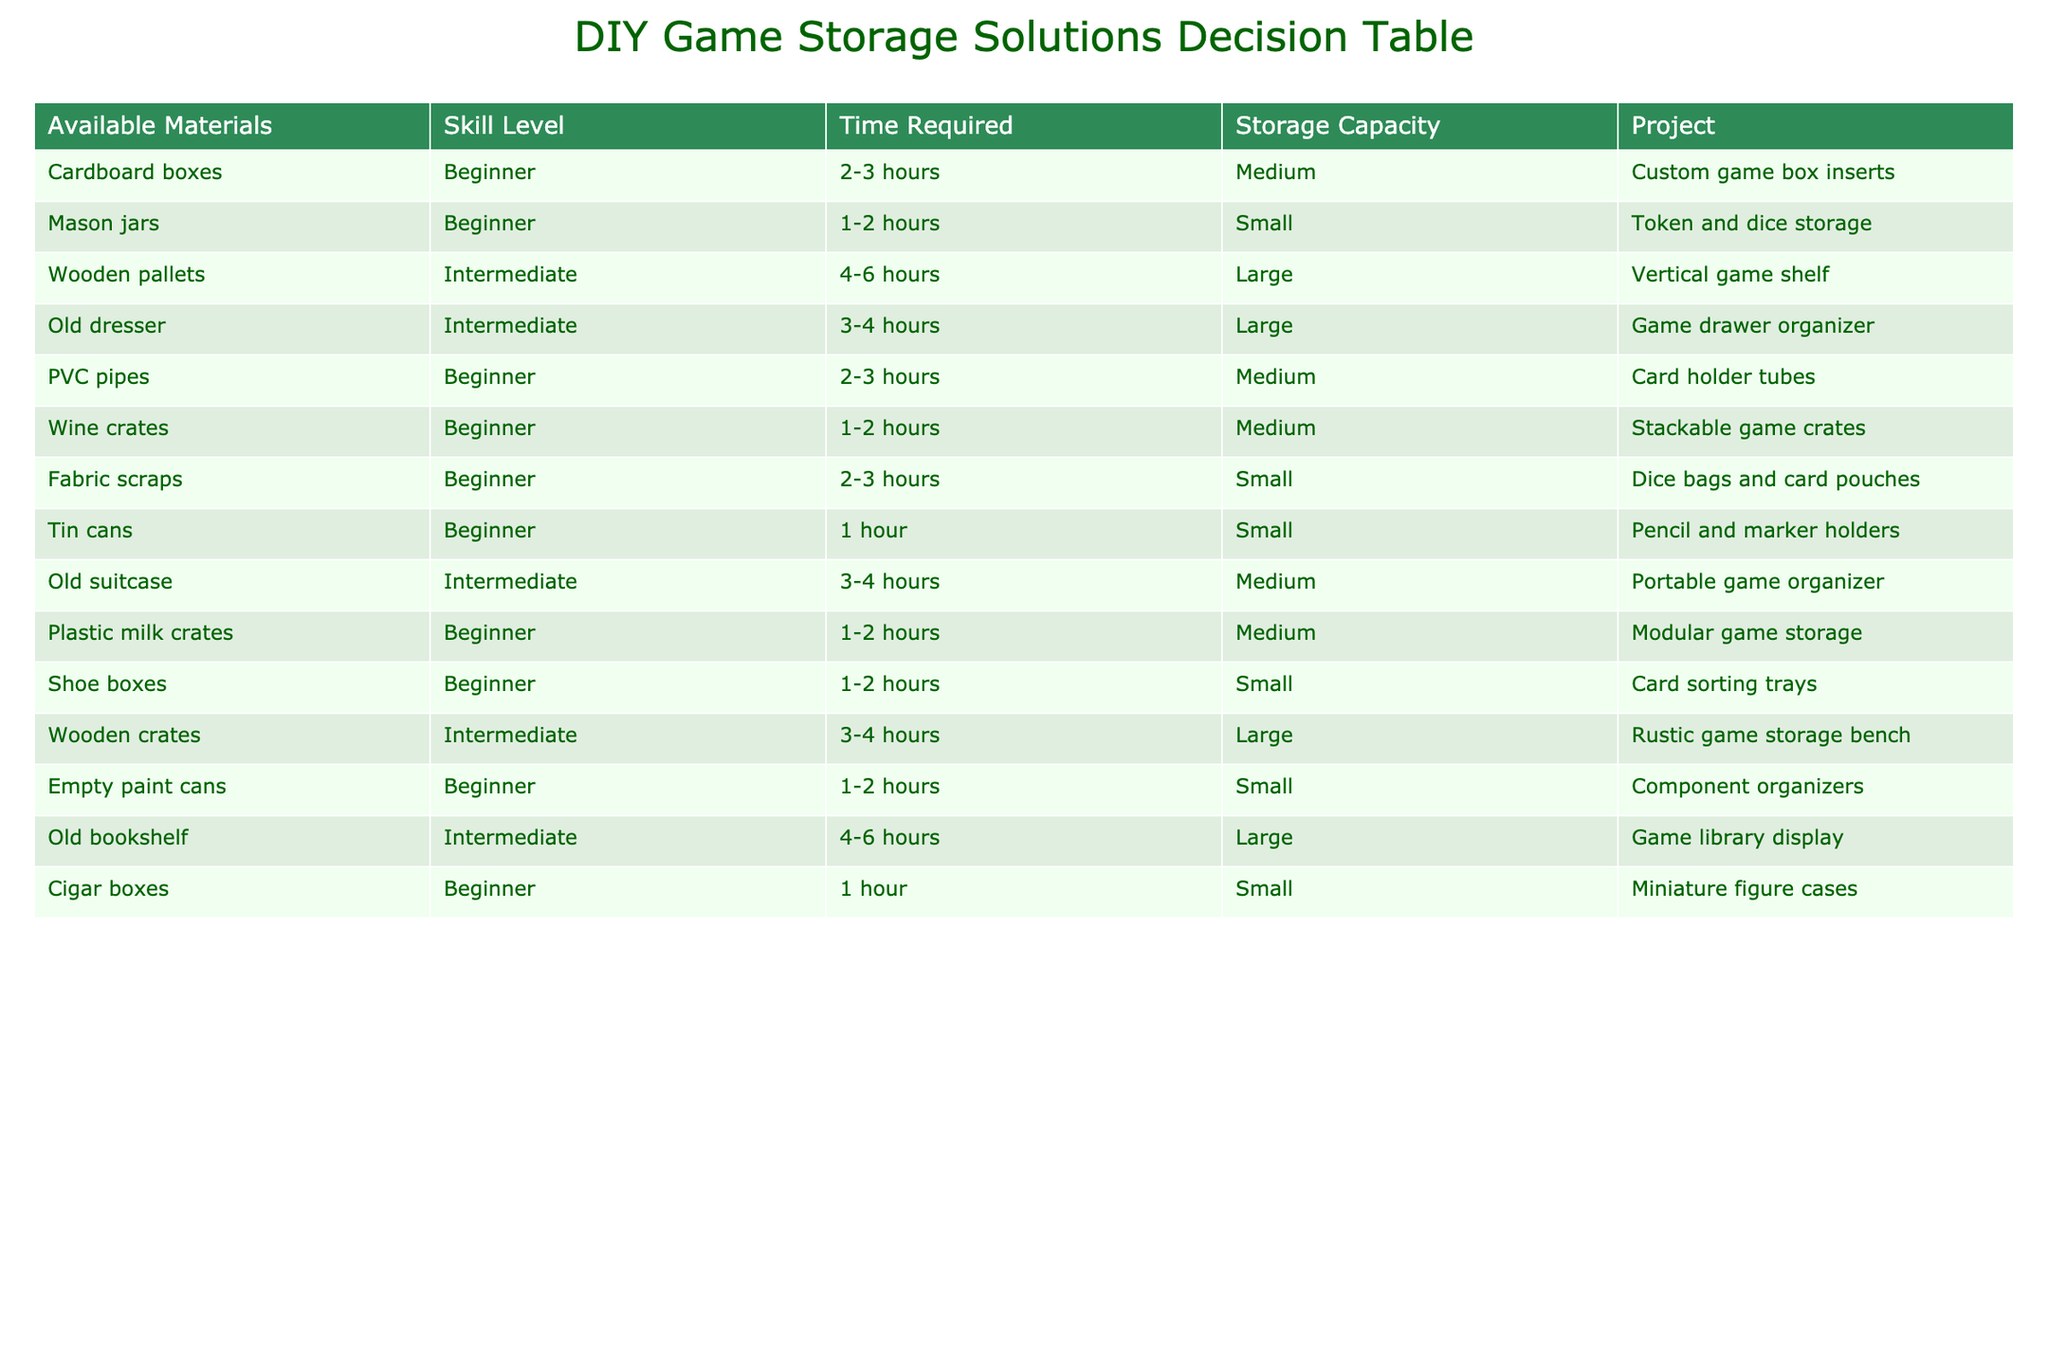What is the skill level required for making custom game box inserts? The project "Custom game box inserts" has the skill level marked as "Beginner" in the table.
Answer: Beginner How many projects require an intermediate skill level? By counting the entire table, there are 4 projects listed with an intermediate skill level.
Answer: 4 What is the storage capacity of the vertical game shelf project? The project "Vertical game shelf" has a storage capacity classified as "Large" in the table.
Answer: Large Which projects can be completed in 1-2 hours and require beginner skill level? Filtering the table for projects that are marked with "Beginner" skill level and have "1-2 hours" time, the projects are: "Mason jars" and "Plastic milk crates".
Answer: Mason jars, Plastic milk crates What is the average time required for all projects? Summing up the time for each project, we have: (2.5 + 1.5 + 5 + 3.5 + 2.5 + 1.5 + 2.5 + 1 + 3.5 + 1.5 + 3.5 + 5 + 1.5 + 1)/14 = 2.5 hours. So the average time required is 2.5 hours.
Answer: 2.5 hours Are there any projects that require more than 4 hours and offer a large storage capacity? Yes, there are two projects with this requirement: "Wooden pallets" and "Old bookshelf," both requiring intermediate skill levels and offering large storage capacity.
Answer: Yes What project utilizes old suitcases, and what is its storage capacity? The project "Portable game organizer" utilizes old suitcases and has a storage capacity of "Medium".
Answer: Medium Which project requires the least amount of time to complete? The project "Pencil and marker holders" made from tin cans requires only 1 hour to complete, making it the least time-consuming project in the table.
Answer: 1 hour How many projects with a small storage capacity are suitable for beginners? There are 4 beginner-level projects featuring a small storage capacity: "Mason jars," "Dice bags and card pouches," "Pencil and marker holders," and "Card sorting trays."
Answer: 4 